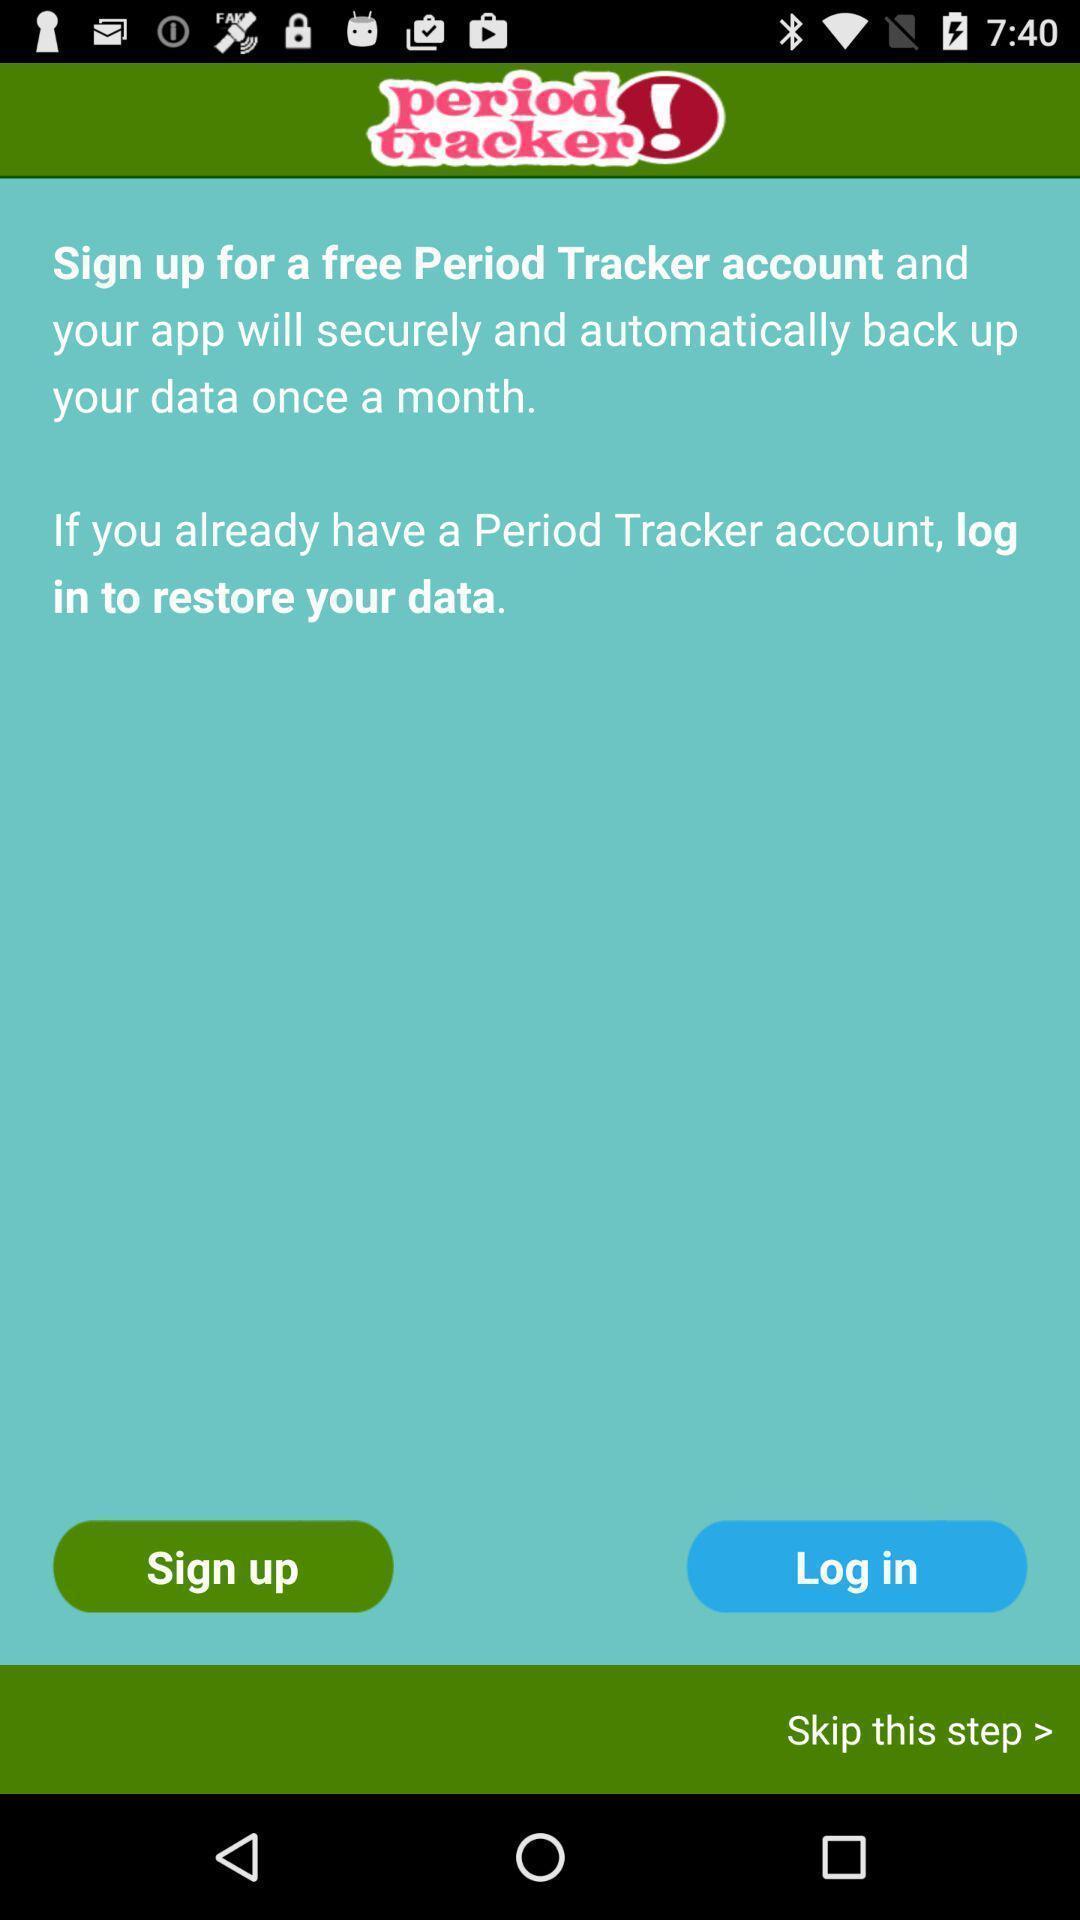Describe the key features of this screenshot. Welcome displaying to sign in to an menstruation application. 